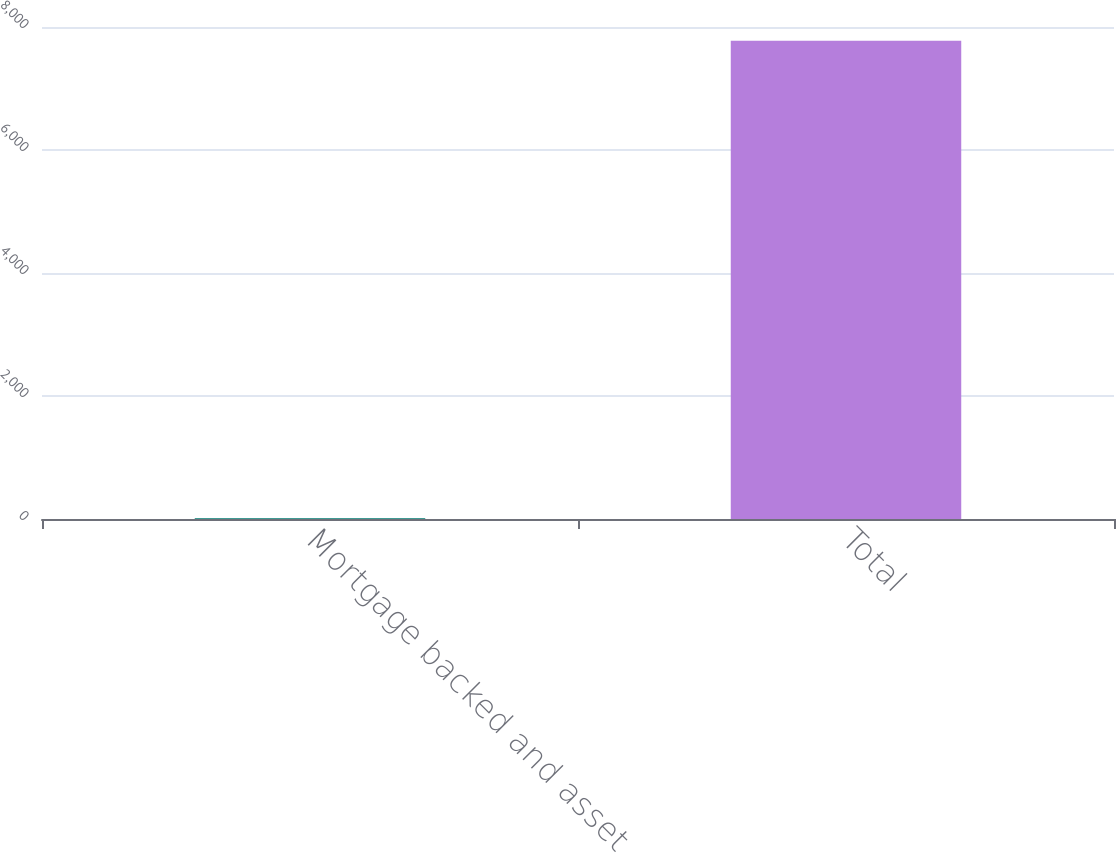<chart> <loc_0><loc_0><loc_500><loc_500><bar_chart><fcel>Mortgage backed and asset<fcel>Total<nl><fcel>11<fcel>7777<nl></chart> 